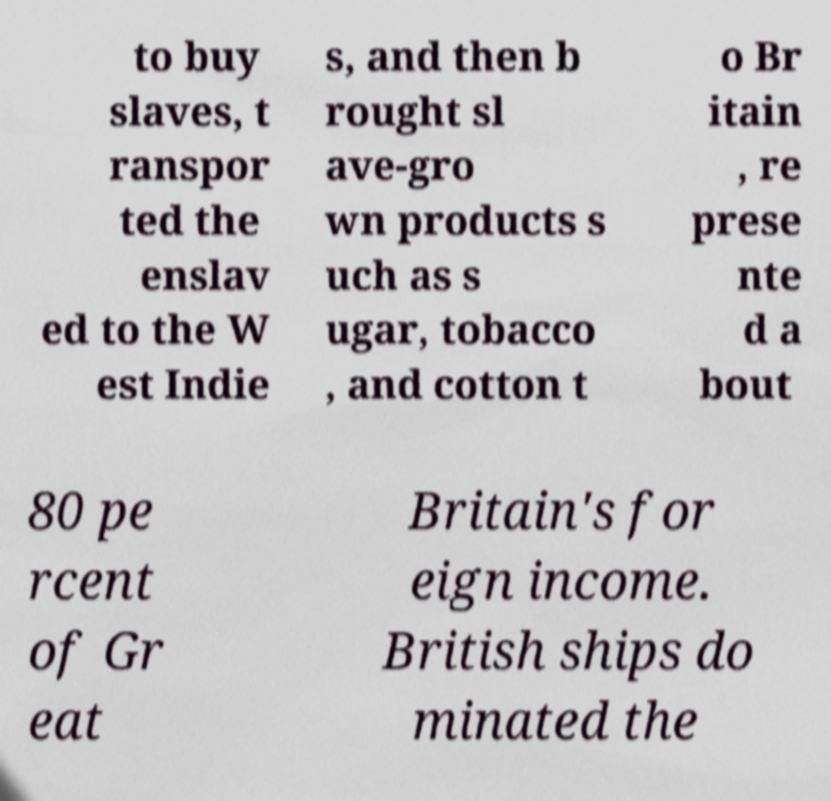Could you extract and type out the text from this image? to buy slaves, t ranspor ted the enslav ed to the W est Indie s, and then b rought sl ave-gro wn products s uch as s ugar, tobacco , and cotton t o Br itain , re prese nte d a bout 80 pe rcent of Gr eat Britain's for eign income. British ships do minated the 